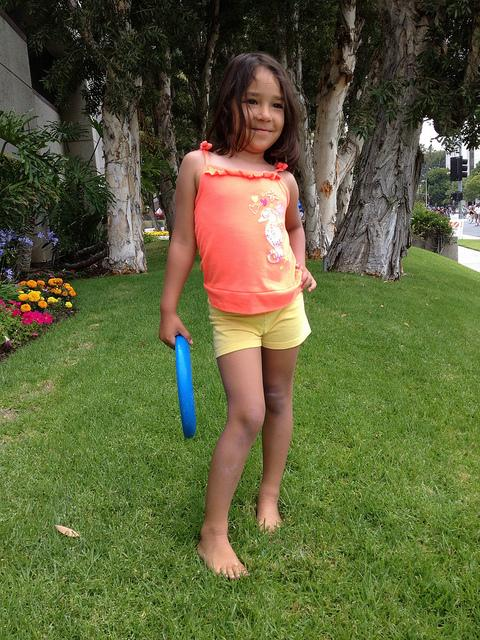The girl is positioning her body in the way a model does by doing what?

Choices:
A) walking
B) posing
C) crying
D) twirling posing 